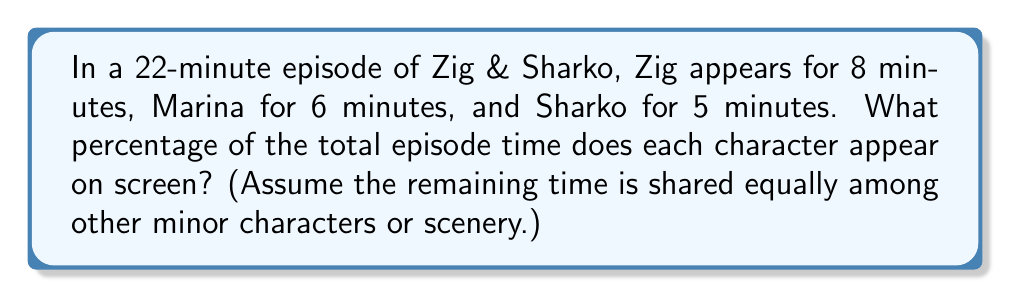Provide a solution to this math problem. To solve this problem, we need to follow these steps:

1. Calculate the total time for main characters:
   $8 + 6 + 5 = 19$ minutes

2. Calculate the percentage for each character:

   For Zig:
   $$\frac{\text{Zig's time}}{\text{Total episode time}} \times 100\% = \frac{8}{22} \times 100\% \approx 36.36\%$$

   For Marina:
   $$\frac{\text{Marina's time}}{\text{Total episode time}} \times 100\% = \frac{6}{22} \times 100\% \approx 27.27\%$$

   For Sharko:
   $$\frac{\text{Sharko's time}}{\text{Total episode time}} \times 100\% = \frac{5}{22} \times 100\% \approx 22.73\%$$

3. The remaining time:
   $$\frac{22 - 19}{22} \times 100\% = \frac{3}{22} \times 100\% \approx 13.64\%$$

   This is shared among other minor characters or scenery.
Answer: Zig: 36.36%
Marina: 27.27%
Sharko: 22.73% 